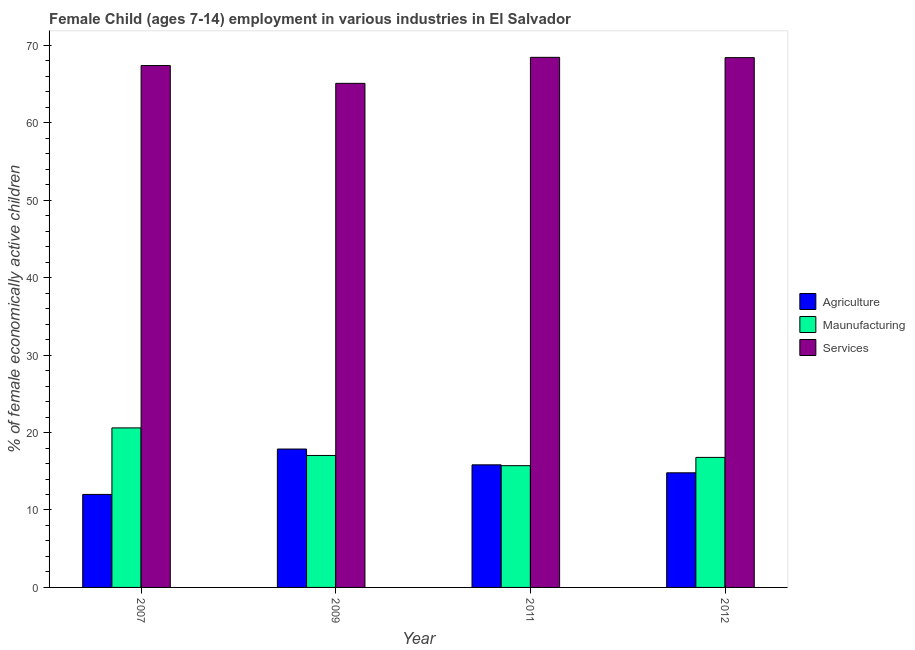How many different coloured bars are there?
Make the answer very short. 3. Are the number of bars per tick equal to the number of legend labels?
Make the answer very short. Yes. Are the number of bars on each tick of the X-axis equal?
Keep it short and to the point. Yes. How many bars are there on the 4th tick from the left?
Ensure brevity in your answer.  3. In how many cases, is the number of bars for a given year not equal to the number of legend labels?
Ensure brevity in your answer.  0. What is the percentage of economically active children in manufacturing in 2009?
Ensure brevity in your answer.  17.04. Across all years, what is the maximum percentage of economically active children in agriculture?
Provide a succinct answer. 17.87. Across all years, what is the minimum percentage of economically active children in manufacturing?
Ensure brevity in your answer.  15.72. In which year was the percentage of economically active children in agriculture minimum?
Make the answer very short. 2007. What is the total percentage of economically active children in agriculture in the graph?
Your answer should be very brief. 60.51. What is the difference between the percentage of economically active children in manufacturing in 2009 and that in 2011?
Provide a succinct answer. 1.32. What is the difference between the percentage of economically active children in agriculture in 2007 and the percentage of economically active children in services in 2012?
Keep it short and to the point. -2.79. What is the average percentage of economically active children in manufacturing per year?
Provide a short and direct response. 17.54. What is the ratio of the percentage of economically active children in services in 2009 to that in 2012?
Provide a succinct answer. 0.95. What is the difference between the highest and the second highest percentage of economically active children in services?
Give a very brief answer. 0.04. What is the difference between the highest and the lowest percentage of economically active children in services?
Your response must be concise. 3.36. In how many years, is the percentage of economically active children in services greater than the average percentage of economically active children in services taken over all years?
Your answer should be very brief. 3. Is the sum of the percentage of economically active children in agriculture in 2009 and 2012 greater than the maximum percentage of economically active children in services across all years?
Offer a very short reply. Yes. What does the 1st bar from the left in 2011 represents?
Provide a short and direct response. Agriculture. What does the 1st bar from the right in 2007 represents?
Your response must be concise. Services. How many bars are there?
Provide a short and direct response. 12. Are all the bars in the graph horizontal?
Your answer should be very brief. No. How many years are there in the graph?
Offer a very short reply. 4. Does the graph contain any zero values?
Keep it short and to the point. No. Does the graph contain grids?
Make the answer very short. No. Where does the legend appear in the graph?
Your response must be concise. Center right. How many legend labels are there?
Provide a succinct answer. 3. What is the title of the graph?
Your answer should be very brief. Female Child (ages 7-14) employment in various industries in El Salvador. Does "Central government" appear as one of the legend labels in the graph?
Offer a very short reply. No. What is the label or title of the Y-axis?
Ensure brevity in your answer.  % of female economically active children. What is the % of female economically active children of Agriculture in 2007?
Your response must be concise. 12.01. What is the % of female economically active children in Maunufacturing in 2007?
Make the answer very short. 20.6. What is the % of female economically active children of Services in 2007?
Offer a very short reply. 67.39. What is the % of female economically active children of Agriculture in 2009?
Your response must be concise. 17.87. What is the % of female economically active children in Maunufacturing in 2009?
Your answer should be compact. 17.04. What is the % of female economically active children of Services in 2009?
Your answer should be very brief. 65.09. What is the % of female economically active children of Agriculture in 2011?
Your answer should be compact. 15.83. What is the % of female economically active children in Maunufacturing in 2011?
Offer a terse response. 15.72. What is the % of female economically active children in Services in 2011?
Keep it short and to the point. 68.45. What is the % of female economically active children in Maunufacturing in 2012?
Give a very brief answer. 16.79. What is the % of female economically active children of Services in 2012?
Offer a terse response. 68.41. Across all years, what is the maximum % of female economically active children in Agriculture?
Offer a very short reply. 17.87. Across all years, what is the maximum % of female economically active children of Maunufacturing?
Your response must be concise. 20.6. Across all years, what is the maximum % of female economically active children of Services?
Provide a succinct answer. 68.45. Across all years, what is the minimum % of female economically active children in Agriculture?
Ensure brevity in your answer.  12.01. Across all years, what is the minimum % of female economically active children in Maunufacturing?
Your answer should be very brief. 15.72. Across all years, what is the minimum % of female economically active children of Services?
Provide a succinct answer. 65.09. What is the total % of female economically active children in Agriculture in the graph?
Offer a terse response. 60.51. What is the total % of female economically active children of Maunufacturing in the graph?
Provide a succinct answer. 70.15. What is the total % of female economically active children of Services in the graph?
Give a very brief answer. 269.34. What is the difference between the % of female economically active children in Agriculture in 2007 and that in 2009?
Give a very brief answer. -5.86. What is the difference between the % of female economically active children of Maunufacturing in 2007 and that in 2009?
Provide a short and direct response. 3.56. What is the difference between the % of female economically active children in Services in 2007 and that in 2009?
Keep it short and to the point. 2.3. What is the difference between the % of female economically active children in Agriculture in 2007 and that in 2011?
Offer a terse response. -3.82. What is the difference between the % of female economically active children of Maunufacturing in 2007 and that in 2011?
Make the answer very short. 4.88. What is the difference between the % of female economically active children in Services in 2007 and that in 2011?
Your answer should be compact. -1.06. What is the difference between the % of female economically active children in Agriculture in 2007 and that in 2012?
Your answer should be compact. -2.79. What is the difference between the % of female economically active children of Maunufacturing in 2007 and that in 2012?
Keep it short and to the point. 3.81. What is the difference between the % of female economically active children of Services in 2007 and that in 2012?
Give a very brief answer. -1.02. What is the difference between the % of female economically active children of Agriculture in 2009 and that in 2011?
Make the answer very short. 2.04. What is the difference between the % of female economically active children in Maunufacturing in 2009 and that in 2011?
Your answer should be compact. 1.32. What is the difference between the % of female economically active children in Services in 2009 and that in 2011?
Your answer should be compact. -3.36. What is the difference between the % of female economically active children in Agriculture in 2009 and that in 2012?
Offer a very short reply. 3.07. What is the difference between the % of female economically active children in Maunufacturing in 2009 and that in 2012?
Make the answer very short. 0.25. What is the difference between the % of female economically active children of Services in 2009 and that in 2012?
Keep it short and to the point. -3.32. What is the difference between the % of female economically active children of Maunufacturing in 2011 and that in 2012?
Your response must be concise. -1.07. What is the difference between the % of female economically active children in Agriculture in 2007 and the % of female economically active children in Maunufacturing in 2009?
Ensure brevity in your answer.  -5.03. What is the difference between the % of female economically active children of Agriculture in 2007 and the % of female economically active children of Services in 2009?
Offer a terse response. -53.08. What is the difference between the % of female economically active children of Maunufacturing in 2007 and the % of female economically active children of Services in 2009?
Your response must be concise. -44.49. What is the difference between the % of female economically active children of Agriculture in 2007 and the % of female economically active children of Maunufacturing in 2011?
Ensure brevity in your answer.  -3.71. What is the difference between the % of female economically active children of Agriculture in 2007 and the % of female economically active children of Services in 2011?
Your answer should be compact. -56.44. What is the difference between the % of female economically active children in Maunufacturing in 2007 and the % of female economically active children in Services in 2011?
Provide a short and direct response. -47.85. What is the difference between the % of female economically active children in Agriculture in 2007 and the % of female economically active children in Maunufacturing in 2012?
Provide a short and direct response. -4.78. What is the difference between the % of female economically active children in Agriculture in 2007 and the % of female economically active children in Services in 2012?
Your answer should be compact. -56.4. What is the difference between the % of female economically active children of Maunufacturing in 2007 and the % of female economically active children of Services in 2012?
Offer a terse response. -47.81. What is the difference between the % of female economically active children in Agriculture in 2009 and the % of female economically active children in Maunufacturing in 2011?
Provide a short and direct response. 2.15. What is the difference between the % of female economically active children in Agriculture in 2009 and the % of female economically active children in Services in 2011?
Offer a terse response. -50.58. What is the difference between the % of female economically active children of Maunufacturing in 2009 and the % of female economically active children of Services in 2011?
Your answer should be compact. -51.41. What is the difference between the % of female economically active children in Agriculture in 2009 and the % of female economically active children in Services in 2012?
Your response must be concise. -50.54. What is the difference between the % of female economically active children in Maunufacturing in 2009 and the % of female economically active children in Services in 2012?
Offer a very short reply. -51.37. What is the difference between the % of female economically active children of Agriculture in 2011 and the % of female economically active children of Maunufacturing in 2012?
Make the answer very short. -0.96. What is the difference between the % of female economically active children of Agriculture in 2011 and the % of female economically active children of Services in 2012?
Ensure brevity in your answer.  -52.58. What is the difference between the % of female economically active children of Maunufacturing in 2011 and the % of female economically active children of Services in 2012?
Provide a succinct answer. -52.69. What is the average % of female economically active children of Agriculture per year?
Give a very brief answer. 15.13. What is the average % of female economically active children of Maunufacturing per year?
Make the answer very short. 17.54. What is the average % of female economically active children of Services per year?
Provide a succinct answer. 67.33. In the year 2007, what is the difference between the % of female economically active children of Agriculture and % of female economically active children of Maunufacturing?
Make the answer very short. -8.59. In the year 2007, what is the difference between the % of female economically active children in Agriculture and % of female economically active children in Services?
Offer a terse response. -55.38. In the year 2007, what is the difference between the % of female economically active children in Maunufacturing and % of female economically active children in Services?
Give a very brief answer. -46.79. In the year 2009, what is the difference between the % of female economically active children in Agriculture and % of female economically active children in Maunufacturing?
Provide a short and direct response. 0.83. In the year 2009, what is the difference between the % of female economically active children of Agriculture and % of female economically active children of Services?
Ensure brevity in your answer.  -47.22. In the year 2009, what is the difference between the % of female economically active children of Maunufacturing and % of female economically active children of Services?
Keep it short and to the point. -48.05. In the year 2011, what is the difference between the % of female economically active children of Agriculture and % of female economically active children of Maunufacturing?
Provide a short and direct response. 0.11. In the year 2011, what is the difference between the % of female economically active children of Agriculture and % of female economically active children of Services?
Provide a succinct answer. -52.62. In the year 2011, what is the difference between the % of female economically active children in Maunufacturing and % of female economically active children in Services?
Provide a short and direct response. -52.73. In the year 2012, what is the difference between the % of female economically active children in Agriculture and % of female economically active children in Maunufacturing?
Your answer should be compact. -1.99. In the year 2012, what is the difference between the % of female economically active children of Agriculture and % of female economically active children of Services?
Ensure brevity in your answer.  -53.61. In the year 2012, what is the difference between the % of female economically active children of Maunufacturing and % of female economically active children of Services?
Your answer should be very brief. -51.62. What is the ratio of the % of female economically active children of Agriculture in 2007 to that in 2009?
Offer a terse response. 0.67. What is the ratio of the % of female economically active children in Maunufacturing in 2007 to that in 2009?
Your response must be concise. 1.21. What is the ratio of the % of female economically active children in Services in 2007 to that in 2009?
Offer a terse response. 1.04. What is the ratio of the % of female economically active children in Agriculture in 2007 to that in 2011?
Offer a terse response. 0.76. What is the ratio of the % of female economically active children of Maunufacturing in 2007 to that in 2011?
Offer a terse response. 1.31. What is the ratio of the % of female economically active children of Services in 2007 to that in 2011?
Provide a succinct answer. 0.98. What is the ratio of the % of female economically active children in Agriculture in 2007 to that in 2012?
Ensure brevity in your answer.  0.81. What is the ratio of the % of female economically active children in Maunufacturing in 2007 to that in 2012?
Provide a succinct answer. 1.23. What is the ratio of the % of female economically active children of Services in 2007 to that in 2012?
Give a very brief answer. 0.99. What is the ratio of the % of female economically active children of Agriculture in 2009 to that in 2011?
Provide a succinct answer. 1.13. What is the ratio of the % of female economically active children of Maunufacturing in 2009 to that in 2011?
Give a very brief answer. 1.08. What is the ratio of the % of female economically active children in Services in 2009 to that in 2011?
Ensure brevity in your answer.  0.95. What is the ratio of the % of female economically active children in Agriculture in 2009 to that in 2012?
Keep it short and to the point. 1.21. What is the ratio of the % of female economically active children in Maunufacturing in 2009 to that in 2012?
Offer a terse response. 1.01. What is the ratio of the % of female economically active children of Services in 2009 to that in 2012?
Give a very brief answer. 0.95. What is the ratio of the % of female economically active children of Agriculture in 2011 to that in 2012?
Provide a short and direct response. 1.07. What is the ratio of the % of female economically active children in Maunufacturing in 2011 to that in 2012?
Your answer should be compact. 0.94. What is the difference between the highest and the second highest % of female economically active children in Agriculture?
Make the answer very short. 2.04. What is the difference between the highest and the second highest % of female economically active children in Maunufacturing?
Offer a terse response. 3.56. What is the difference between the highest and the lowest % of female economically active children in Agriculture?
Make the answer very short. 5.86. What is the difference between the highest and the lowest % of female economically active children in Maunufacturing?
Your answer should be compact. 4.88. What is the difference between the highest and the lowest % of female economically active children in Services?
Your response must be concise. 3.36. 